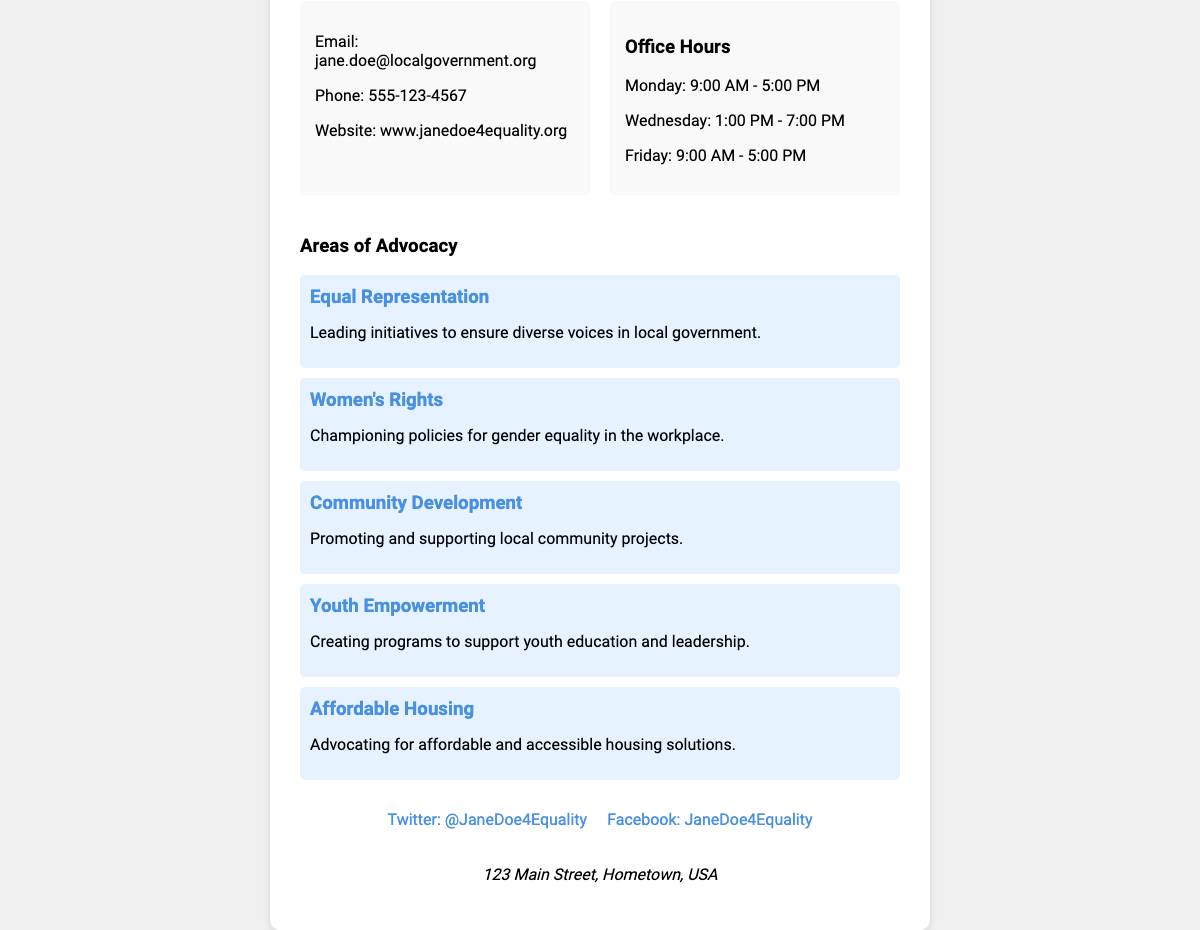what is the name of the councilwoman? The document presents the name in the header section as "Jane Doe."
Answer: Jane Doe what is the email address provided? The email address is mentioned under the contact info section of the document.
Answer: jane.doe@localgovernment.org what are the office hours on Wednesday? The office hours section specifies times for each day, including Wednesday as "1:00 PM - 7:00 PM."
Answer: 1:00 PM - 7:00 PM what is one of the areas of advocacy listed? The document lists various areas of advocacy; for example, "Women's Rights" is one of them.
Answer: Women's Rights how many days per week is the office open? The office hours indicate that the office is open on three different days each week.
Answer: Three what is the website URL provided? The document includes a URL in the contact info section labeled as the website.
Answer: www.janedoe4equality.org which social media platform is linked for updates? The document references social media links, one of which is Twitter.
Answer: Twitter what is the address mentioned on the business card? The document concludes with the address stated in the address section.
Answer: 123 Main Street, Hometown, USA who is the target audience for the advocacy areas? The advocacy areas are focused on various community groups, implied to be diverse and inclusive.
Answer: Community groups 